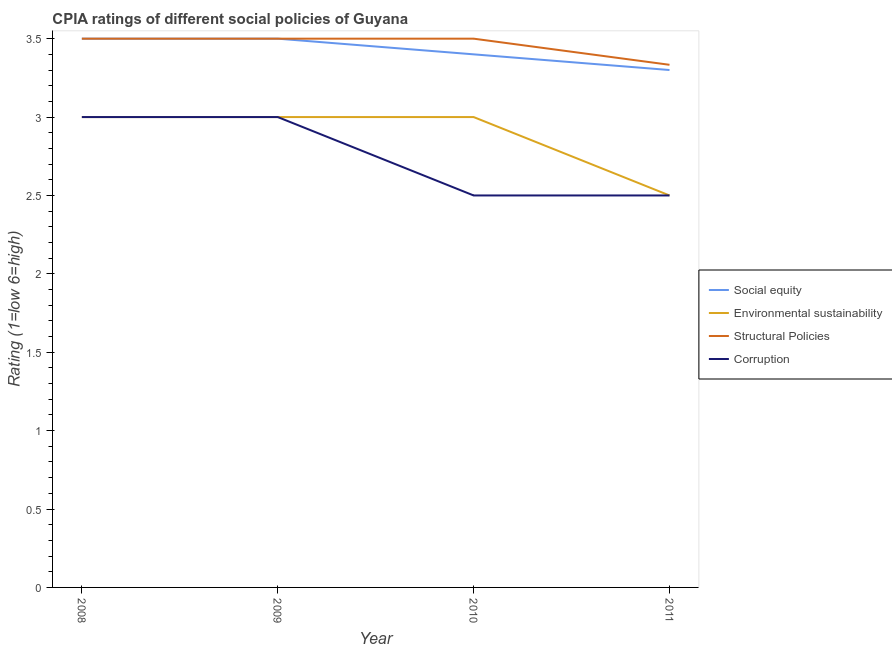How many different coloured lines are there?
Provide a short and direct response. 4. Is the number of lines equal to the number of legend labels?
Your answer should be compact. Yes. What is the cpia rating of structural policies in 2011?
Provide a succinct answer. 3.33. Across all years, what is the maximum cpia rating of structural policies?
Ensure brevity in your answer.  3.5. Across all years, what is the minimum cpia rating of structural policies?
Offer a terse response. 3.33. In which year was the cpia rating of corruption maximum?
Give a very brief answer. 2008. What is the difference between the cpia rating of structural policies in 2009 and that in 2011?
Make the answer very short. 0.17. What is the average cpia rating of social equity per year?
Provide a succinct answer. 3.42. In the year 2011, what is the difference between the cpia rating of environmental sustainability and cpia rating of social equity?
Your response must be concise. -0.8. What is the ratio of the cpia rating of structural policies in 2009 to that in 2011?
Your answer should be compact. 1.05. Is the cpia rating of structural policies in 2008 less than that in 2010?
Give a very brief answer. No. Is the difference between the cpia rating of structural policies in 2009 and 2010 greater than the difference between the cpia rating of corruption in 2009 and 2010?
Your response must be concise. No. What is the difference between the highest and the lowest cpia rating of structural policies?
Your answer should be compact. 0.17. In how many years, is the cpia rating of structural policies greater than the average cpia rating of structural policies taken over all years?
Offer a terse response. 3. Is it the case that in every year, the sum of the cpia rating of social equity and cpia rating of corruption is greater than the sum of cpia rating of environmental sustainability and cpia rating of structural policies?
Ensure brevity in your answer.  Yes. Is it the case that in every year, the sum of the cpia rating of social equity and cpia rating of environmental sustainability is greater than the cpia rating of structural policies?
Keep it short and to the point. Yes. Does the cpia rating of environmental sustainability monotonically increase over the years?
Make the answer very short. No. Is the cpia rating of environmental sustainability strictly less than the cpia rating of social equity over the years?
Your answer should be very brief. Yes. How many lines are there?
Keep it short and to the point. 4. How many years are there in the graph?
Keep it short and to the point. 4. What is the difference between two consecutive major ticks on the Y-axis?
Provide a succinct answer. 0.5. Are the values on the major ticks of Y-axis written in scientific E-notation?
Provide a short and direct response. No. Does the graph contain any zero values?
Provide a succinct answer. No. How many legend labels are there?
Offer a very short reply. 4. How are the legend labels stacked?
Your answer should be compact. Vertical. What is the title of the graph?
Give a very brief answer. CPIA ratings of different social policies of Guyana. Does "Social Protection" appear as one of the legend labels in the graph?
Provide a short and direct response. No. What is the Rating (1=low 6=high) of Social equity in 2008?
Offer a very short reply. 3.5. What is the Rating (1=low 6=high) of Structural Policies in 2008?
Make the answer very short. 3.5. What is the Rating (1=low 6=high) of Social equity in 2009?
Your response must be concise. 3.5. What is the Rating (1=low 6=high) of Environmental sustainability in 2009?
Keep it short and to the point. 3. What is the Rating (1=low 6=high) in Social equity in 2010?
Your answer should be compact. 3.4. What is the Rating (1=low 6=high) in Environmental sustainability in 2010?
Your answer should be compact. 3. What is the Rating (1=low 6=high) of Structural Policies in 2010?
Your answer should be very brief. 3.5. What is the Rating (1=low 6=high) in Corruption in 2010?
Your response must be concise. 2.5. What is the Rating (1=low 6=high) of Structural Policies in 2011?
Your response must be concise. 3.33. Across all years, what is the maximum Rating (1=low 6=high) in Structural Policies?
Ensure brevity in your answer.  3.5. Across all years, what is the maximum Rating (1=low 6=high) in Corruption?
Keep it short and to the point. 3. Across all years, what is the minimum Rating (1=low 6=high) of Social equity?
Make the answer very short. 3.3. Across all years, what is the minimum Rating (1=low 6=high) of Environmental sustainability?
Make the answer very short. 2.5. Across all years, what is the minimum Rating (1=low 6=high) of Structural Policies?
Ensure brevity in your answer.  3.33. Across all years, what is the minimum Rating (1=low 6=high) of Corruption?
Your answer should be very brief. 2.5. What is the total Rating (1=low 6=high) in Social equity in the graph?
Give a very brief answer. 13.7. What is the total Rating (1=low 6=high) of Structural Policies in the graph?
Make the answer very short. 13.83. What is the difference between the Rating (1=low 6=high) in Environmental sustainability in 2008 and that in 2009?
Offer a terse response. 0. What is the difference between the Rating (1=low 6=high) of Corruption in 2008 and that in 2009?
Keep it short and to the point. 0. What is the difference between the Rating (1=low 6=high) of Social equity in 2008 and that in 2010?
Ensure brevity in your answer.  0.1. What is the difference between the Rating (1=low 6=high) in Structural Policies in 2008 and that in 2010?
Your answer should be very brief. 0. What is the difference between the Rating (1=low 6=high) in Corruption in 2008 and that in 2011?
Give a very brief answer. 0.5. What is the difference between the Rating (1=low 6=high) of Social equity in 2009 and that in 2010?
Your answer should be compact. 0.1. What is the difference between the Rating (1=low 6=high) in Corruption in 2009 and that in 2010?
Keep it short and to the point. 0.5. What is the difference between the Rating (1=low 6=high) in Social equity in 2009 and that in 2011?
Your response must be concise. 0.2. What is the difference between the Rating (1=low 6=high) of Environmental sustainability in 2009 and that in 2011?
Your answer should be compact. 0.5. What is the difference between the Rating (1=low 6=high) in Corruption in 2010 and that in 2011?
Keep it short and to the point. 0. What is the difference between the Rating (1=low 6=high) in Environmental sustainability in 2008 and the Rating (1=low 6=high) in Structural Policies in 2009?
Ensure brevity in your answer.  -0.5. What is the difference between the Rating (1=low 6=high) in Structural Policies in 2008 and the Rating (1=low 6=high) in Corruption in 2009?
Provide a succinct answer. 0.5. What is the difference between the Rating (1=low 6=high) in Social equity in 2008 and the Rating (1=low 6=high) in Environmental sustainability in 2010?
Provide a succinct answer. 0.5. What is the difference between the Rating (1=low 6=high) in Social equity in 2008 and the Rating (1=low 6=high) in Structural Policies in 2010?
Provide a succinct answer. 0. What is the difference between the Rating (1=low 6=high) of Environmental sustainability in 2008 and the Rating (1=low 6=high) of Structural Policies in 2010?
Your answer should be very brief. -0.5. What is the difference between the Rating (1=low 6=high) of Structural Policies in 2008 and the Rating (1=low 6=high) of Corruption in 2010?
Keep it short and to the point. 1. What is the difference between the Rating (1=low 6=high) of Social equity in 2008 and the Rating (1=low 6=high) of Structural Policies in 2011?
Keep it short and to the point. 0.17. What is the difference between the Rating (1=low 6=high) in Social equity in 2008 and the Rating (1=low 6=high) in Corruption in 2011?
Your answer should be compact. 1. What is the difference between the Rating (1=low 6=high) in Social equity in 2009 and the Rating (1=low 6=high) in Structural Policies in 2010?
Your answer should be compact. 0. What is the difference between the Rating (1=low 6=high) in Environmental sustainability in 2009 and the Rating (1=low 6=high) in Structural Policies in 2010?
Keep it short and to the point. -0.5. What is the difference between the Rating (1=low 6=high) of Environmental sustainability in 2009 and the Rating (1=low 6=high) of Corruption in 2010?
Provide a short and direct response. 0.5. What is the difference between the Rating (1=low 6=high) of Social equity in 2009 and the Rating (1=low 6=high) of Structural Policies in 2011?
Make the answer very short. 0.17. What is the difference between the Rating (1=low 6=high) in Social equity in 2010 and the Rating (1=low 6=high) in Environmental sustainability in 2011?
Your answer should be very brief. 0.9. What is the difference between the Rating (1=low 6=high) in Social equity in 2010 and the Rating (1=low 6=high) in Structural Policies in 2011?
Keep it short and to the point. 0.07. What is the difference between the Rating (1=low 6=high) of Social equity in 2010 and the Rating (1=low 6=high) of Corruption in 2011?
Give a very brief answer. 0.9. What is the difference between the Rating (1=low 6=high) in Environmental sustainability in 2010 and the Rating (1=low 6=high) in Corruption in 2011?
Give a very brief answer. 0.5. What is the difference between the Rating (1=low 6=high) in Structural Policies in 2010 and the Rating (1=low 6=high) in Corruption in 2011?
Your answer should be compact. 1. What is the average Rating (1=low 6=high) in Social equity per year?
Provide a succinct answer. 3.42. What is the average Rating (1=low 6=high) in Environmental sustainability per year?
Ensure brevity in your answer.  2.88. What is the average Rating (1=low 6=high) of Structural Policies per year?
Your answer should be very brief. 3.46. What is the average Rating (1=low 6=high) of Corruption per year?
Your response must be concise. 2.75. In the year 2008, what is the difference between the Rating (1=low 6=high) of Social equity and Rating (1=low 6=high) of Environmental sustainability?
Offer a very short reply. 0.5. In the year 2008, what is the difference between the Rating (1=low 6=high) in Social equity and Rating (1=low 6=high) in Corruption?
Your answer should be compact. 0.5. In the year 2008, what is the difference between the Rating (1=low 6=high) of Environmental sustainability and Rating (1=low 6=high) of Structural Policies?
Offer a terse response. -0.5. In the year 2008, what is the difference between the Rating (1=low 6=high) in Environmental sustainability and Rating (1=low 6=high) in Corruption?
Give a very brief answer. 0. In the year 2009, what is the difference between the Rating (1=low 6=high) in Environmental sustainability and Rating (1=low 6=high) in Structural Policies?
Provide a short and direct response. -0.5. In the year 2010, what is the difference between the Rating (1=low 6=high) of Social equity and Rating (1=low 6=high) of Structural Policies?
Give a very brief answer. -0.1. In the year 2010, what is the difference between the Rating (1=low 6=high) of Environmental sustainability and Rating (1=low 6=high) of Corruption?
Offer a terse response. 0.5. In the year 2010, what is the difference between the Rating (1=low 6=high) in Structural Policies and Rating (1=low 6=high) in Corruption?
Keep it short and to the point. 1. In the year 2011, what is the difference between the Rating (1=low 6=high) in Social equity and Rating (1=low 6=high) in Structural Policies?
Offer a terse response. -0.03. In the year 2011, what is the difference between the Rating (1=low 6=high) of Environmental sustainability and Rating (1=low 6=high) of Structural Policies?
Offer a very short reply. -0.83. In the year 2011, what is the difference between the Rating (1=low 6=high) of Environmental sustainability and Rating (1=low 6=high) of Corruption?
Keep it short and to the point. 0. In the year 2011, what is the difference between the Rating (1=low 6=high) in Structural Policies and Rating (1=low 6=high) in Corruption?
Make the answer very short. 0.83. What is the ratio of the Rating (1=low 6=high) of Environmental sustainability in 2008 to that in 2009?
Offer a terse response. 1. What is the ratio of the Rating (1=low 6=high) in Social equity in 2008 to that in 2010?
Provide a short and direct response. 1.03. What is the ratio of the Rating (1=low 6=high) in Environmental sustainability in 2008 to that in 2010?
Offer a very short reply. 1. What is the ratio of the Rating (1=low 6=high) in Structural Policies in 2008 to that in 2010?
Give a very brief answer. 1. What is the ratio of the Rating (1=low 6=high) in Social equity in 2008 to that in 2011?
Ensure brevity in your answer.  1.06. What is the ratio of the Rating (1=low 6=high) of Corruption in 2008 to that in 2011?
Ensure brevity in your answer.  1.2. What is the ratio of the Rating (1=low 6=high) in Social equity in 2009 to that in 2010?
Provide a short and direct response. 1.03. What is the ratio of the Rating (1=low 6=high) of Environmental sustainability in 2009 to that in 2010?
Offer a very short reply. 1. What is the ratio of the Rating (1=low 6=high) of Structural Policies in 2009 to that in 2010?
Provide a succinct answer. 1. What is the ratio of the Rating (1=low 6=high) of Social equity in 2009 to that in 2011?
Your response must be concise. 1.06. What is the ratio of the Rating (1=low 6=high) of Environmental sustainability in 2009 to that in 2011?
Offer a very short reply. 1.2. What is the ratio of the Rating (1=low 6=high) in Corruption in 2009 to that in 2011?
Your answer should be compact. 1.2. What is the ratio of the Rating (1=low 6=high) in Social equity in 2010 to that in 2011?
Keep it short and to the point. 1.03. What is the difference between the highest and the second highest Rating (1=low 6=high) in Social equity?
Make the answer very short. 0. What is the difference between the highest and the second highest Rating (1=low 6=high) in Environmental sustainability?
Your response must be concise. 0. What is the difference between the highest and the second highest Rating (1=low 6=high) in Structural Policies?
Give a very brief answer. 0. What is the difference between the highest and the lowest Rating (1=low 6=high) in Structural Policies?
Your response must be concise. 0.17. What is the difference between the highest and the lowest Rating (1=low 6=high) of Corruption?
Keep it short and to the point. 0.5. 